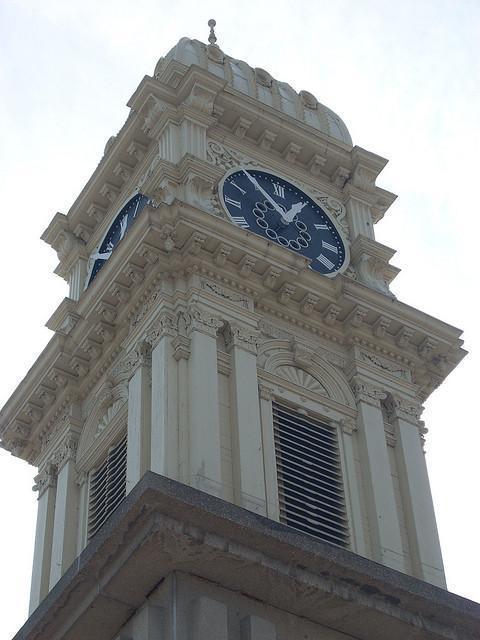How many clocks are not visible?
Give a very brief answer. 2. 